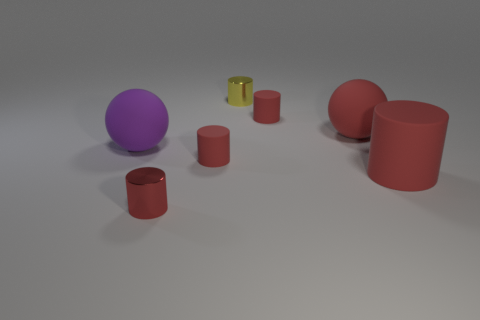How many red cylinders must be subtracted to get 2 red cylinders? 2 Subtract all cyan spheres. How many red cylinders are left? 4 Subtract all big rubber cylinders. How many cylinders are left? 4 Subtract all blue cylinders. Subtract all blue cubes. How many cylinders are left? 5 Add 1 small red shiny cylinders. How many objects exist? 8 Subtract all cylinders. How many objects are left? 2 Subtract all big cyan shiny cubes. Subtract all small yellow shiny things. How many objects are left? 6 Add 6 large matte things. How many large matte things are left? 9 Add 7 small metal cylinders. How many small metal cylinders exist? 9 Subtract 0 brown spheres. How many objects are left? 7 